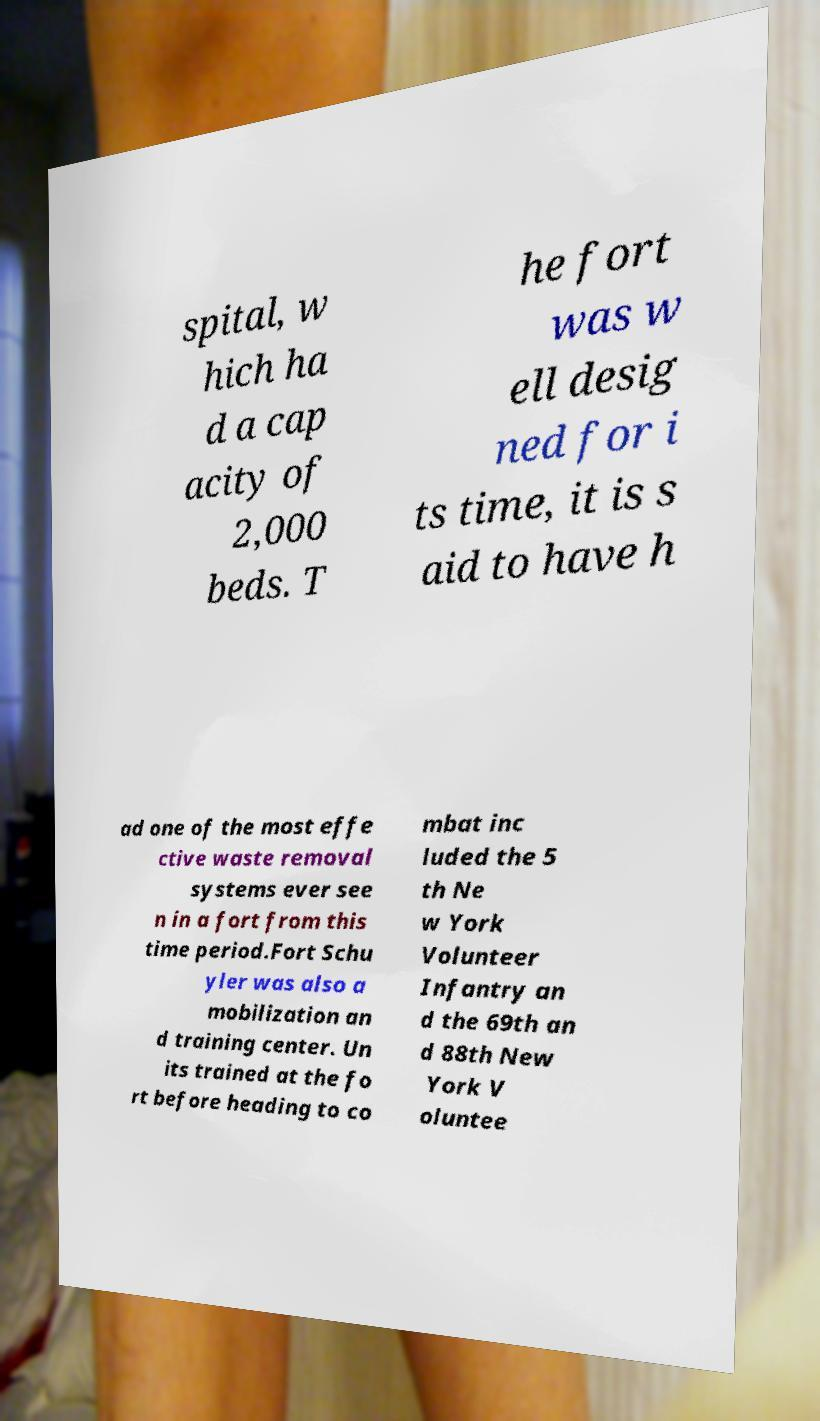Can you accurately transcribe the text from the provided image for me? spital, w hich ha d a cap acity of 2,000 beds. T he fort was w ell desig ned for i ts time, it is s aid to have h ad one of the most effe ctive waste removal systems ever see n in a fort from this time period.Fort Schu yler was also a mobilization an d training center. Un its trained at the fo rt before heading to co mbat inc luded the 5 th Ne w York Volunteer Infantry an d the 69th an d 88th New York V oluntee 